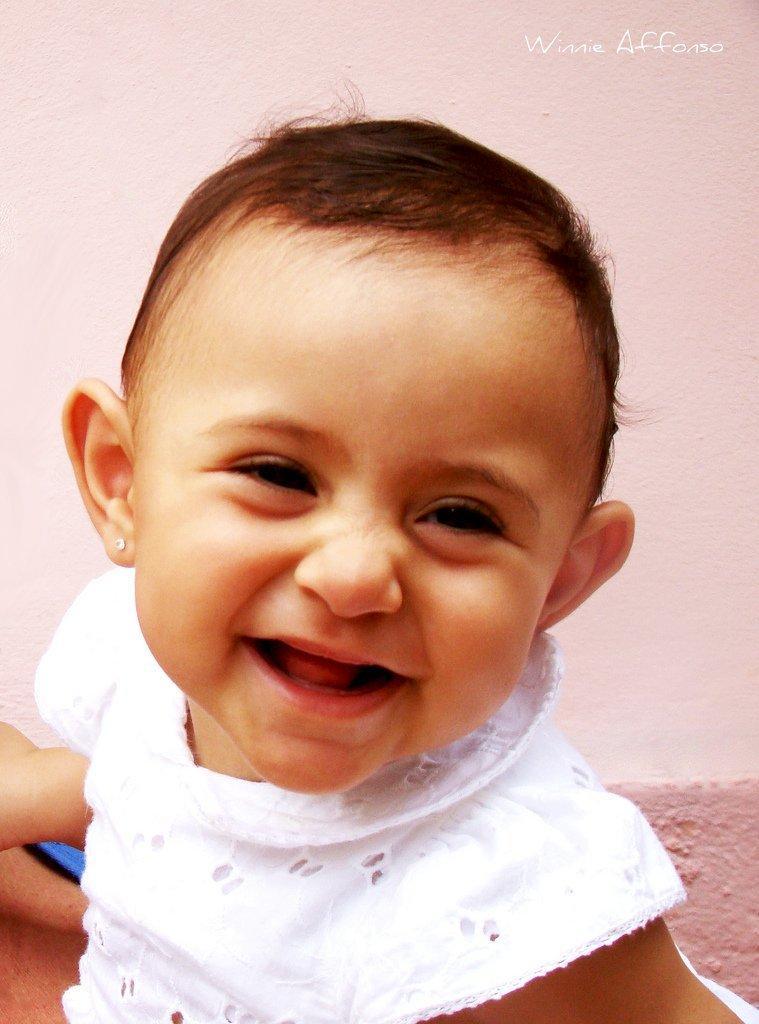Could you give a brief overview of what you see in this image? In this picture there is a kid smiling. In the background of the image we can see the wall. In the top right side of the image we can see text.   